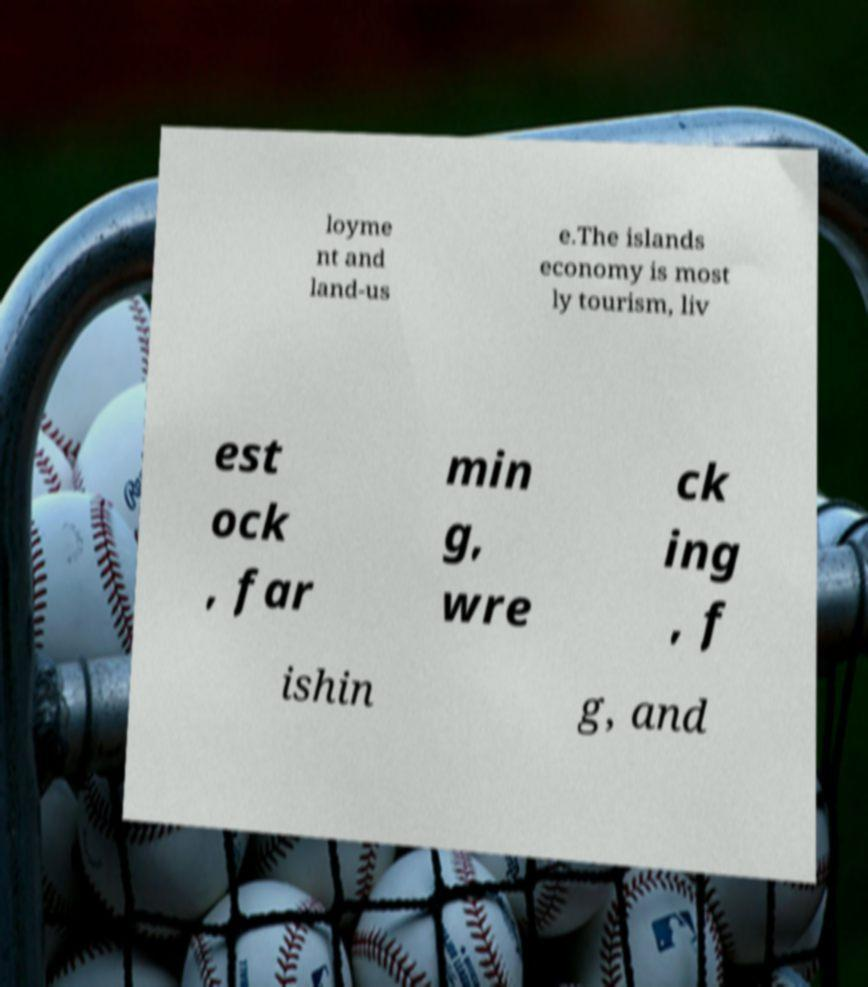Could you extract and type out the text from this image? loyme nt and land-us e.The islands economy is most ly tourism, liv est ock , far min g, wre ck ing , f ishin g, and 